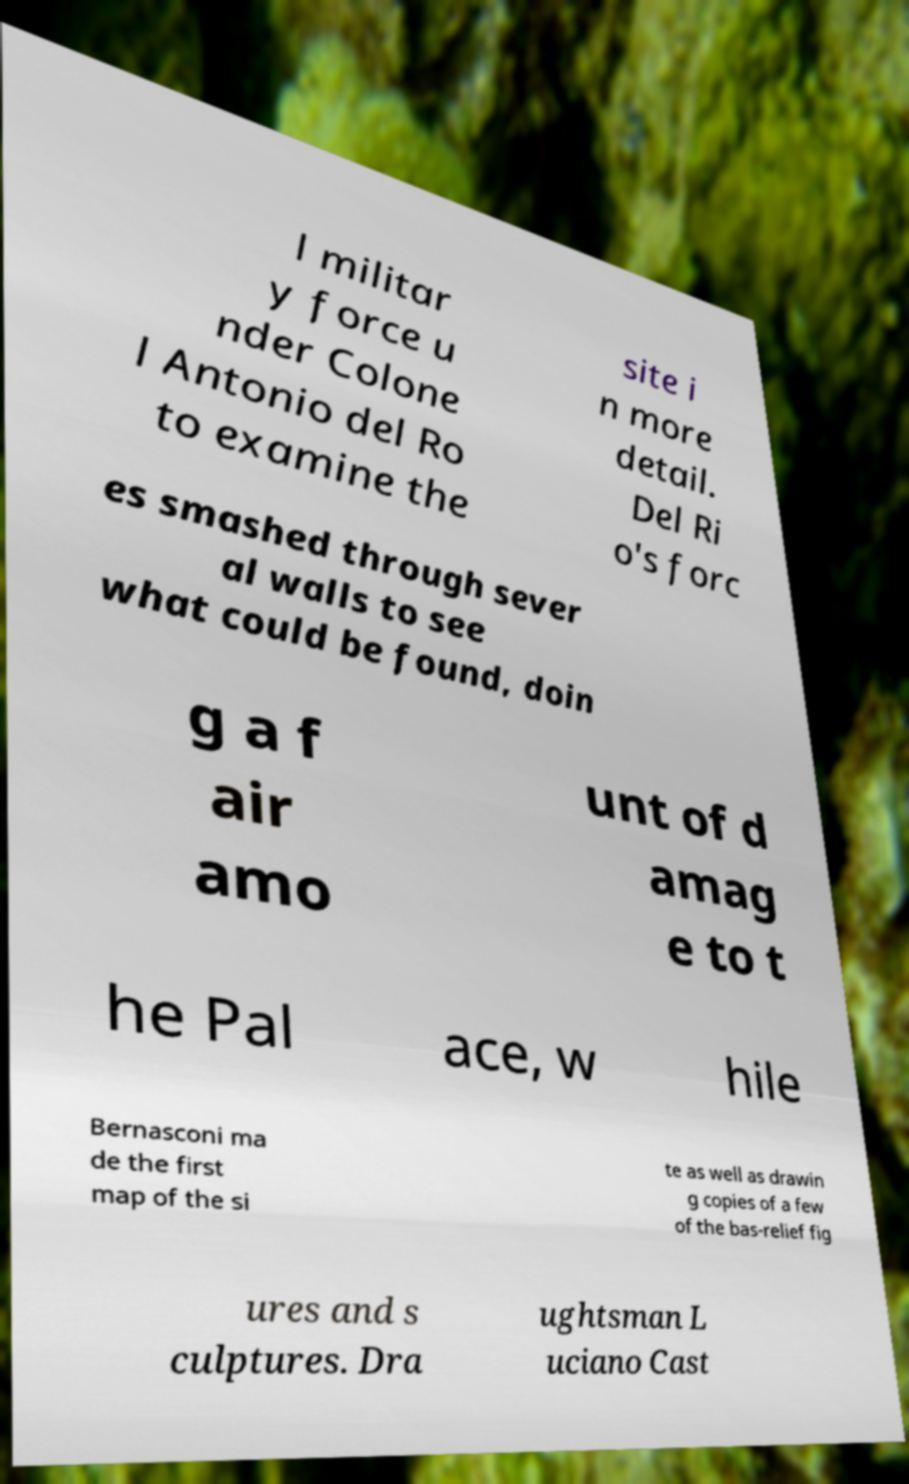Can you accurately transcribe the text from the provided image for me? l militar y force u nder Colone l Antonio del Ro to examine the site i n more detail. Del Ri o's forc es smashed through sever al walls to see what could be found, doin g a f air amo unt of d amag e to t he Pal ace, w hile Bernasconi ma de the first map of the si te as well as drawin g copies of a few of the bas-relief fig ures and s culptures. Dra ughtsman L uciano Cast 